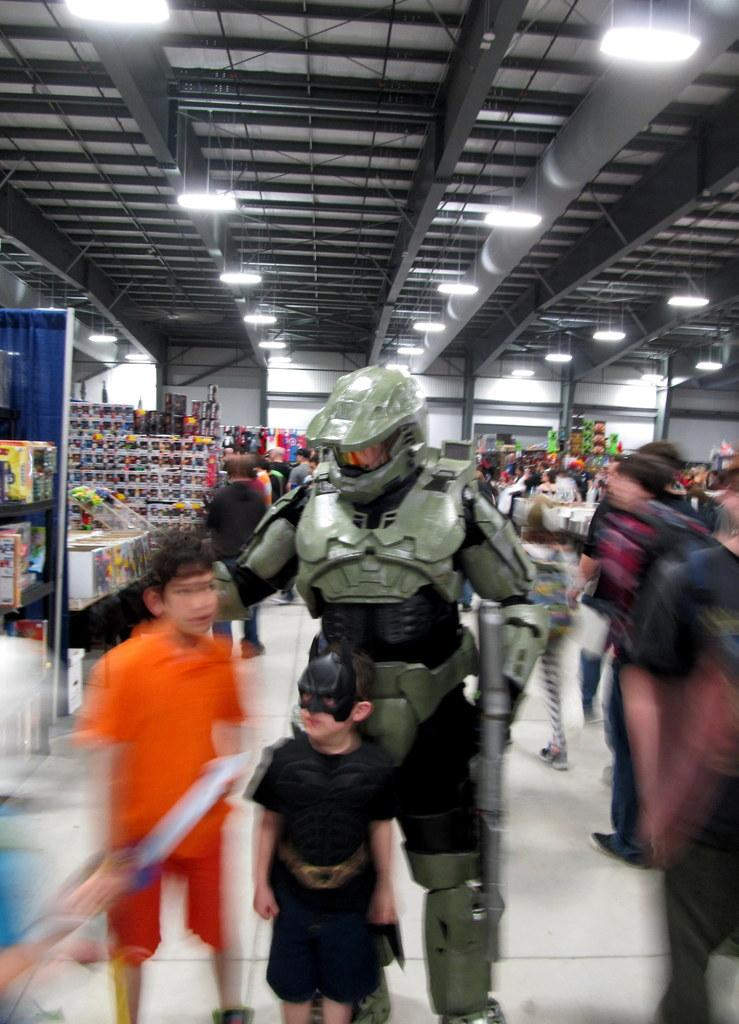What is the person in the image doing? The person is standing in a store. What is the person wearing in the image? The person is wearing a robot costume. Are there any other people in the store? Yes, other people are present in the store. What can be seen on the shelves in the store? There are items in the shelves. What can be seen at the top of the store? There are lights at the top. What type of dirt can be seen in the yard outside the store? There is no yard or dirt visible in the image; it is set inside a store. 